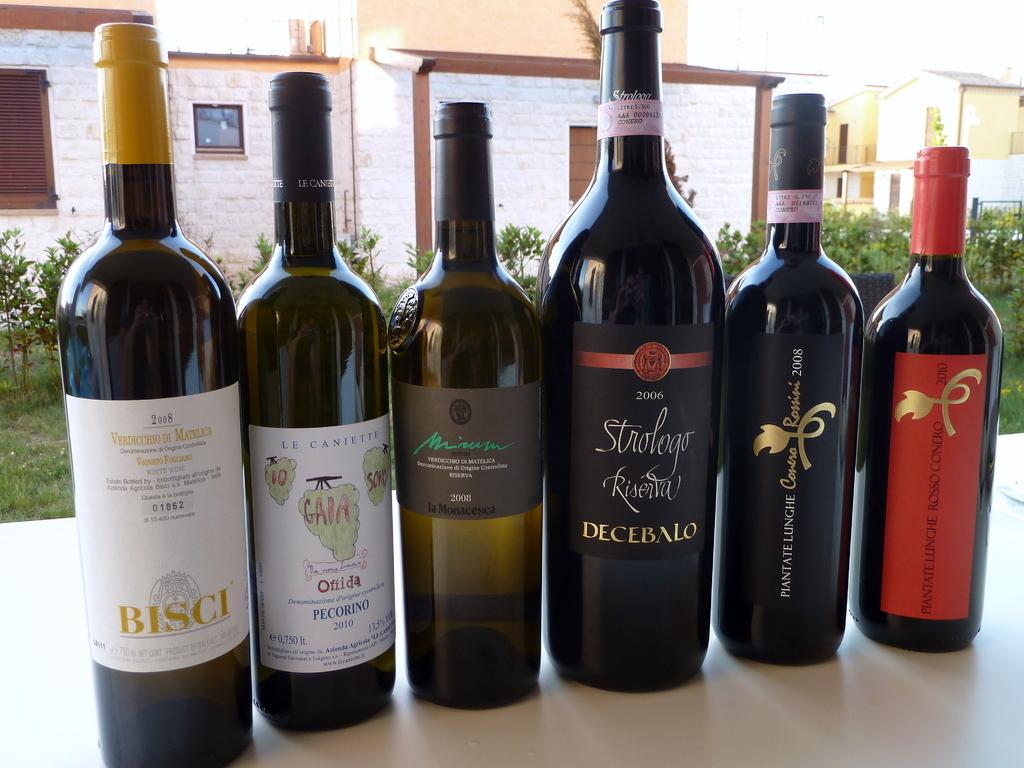What is the year of the bottle in the middle with the red ribbon across the middle?
Offer a terse response. 2006. What is the name of the wine on the left?
Keep it short and to the point. Bisci. 